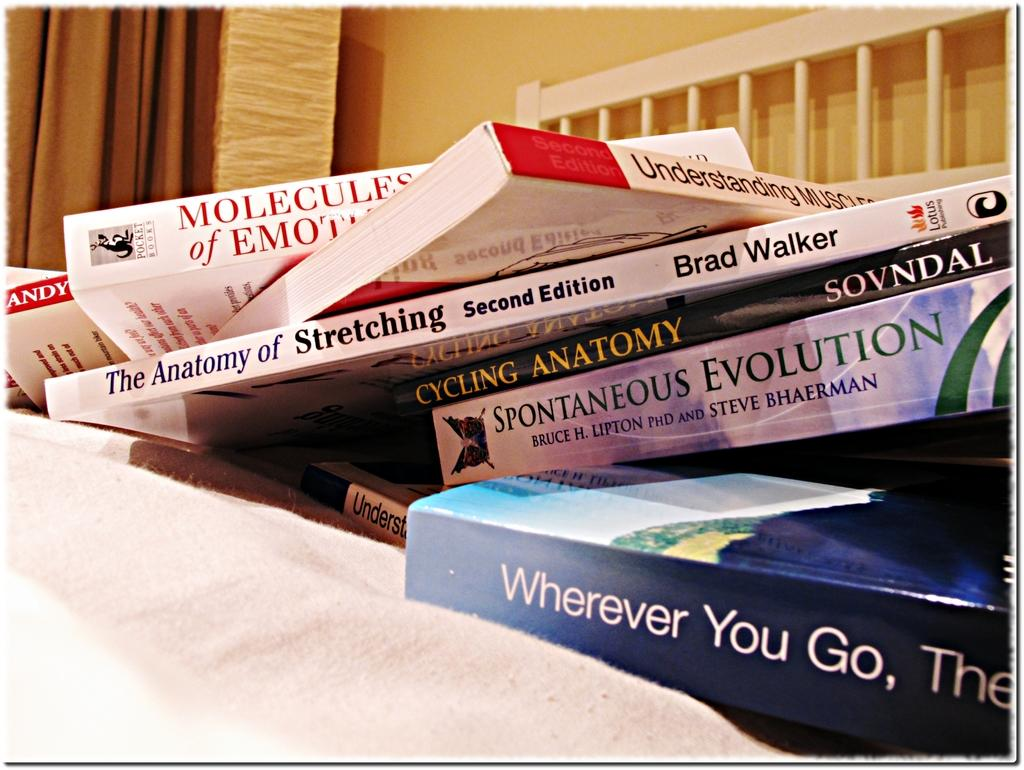Provide a one-sentence caption for the provided image. Books laying on a bed with one entitled Wherever You Go. 